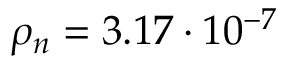Convert formula to latex. <formula><loc_0><loc_0><loc_500><loc_500>\rho _ { n } = 3 . 1 7 \cdot 1 0 ^ { - 7 }</formula> 